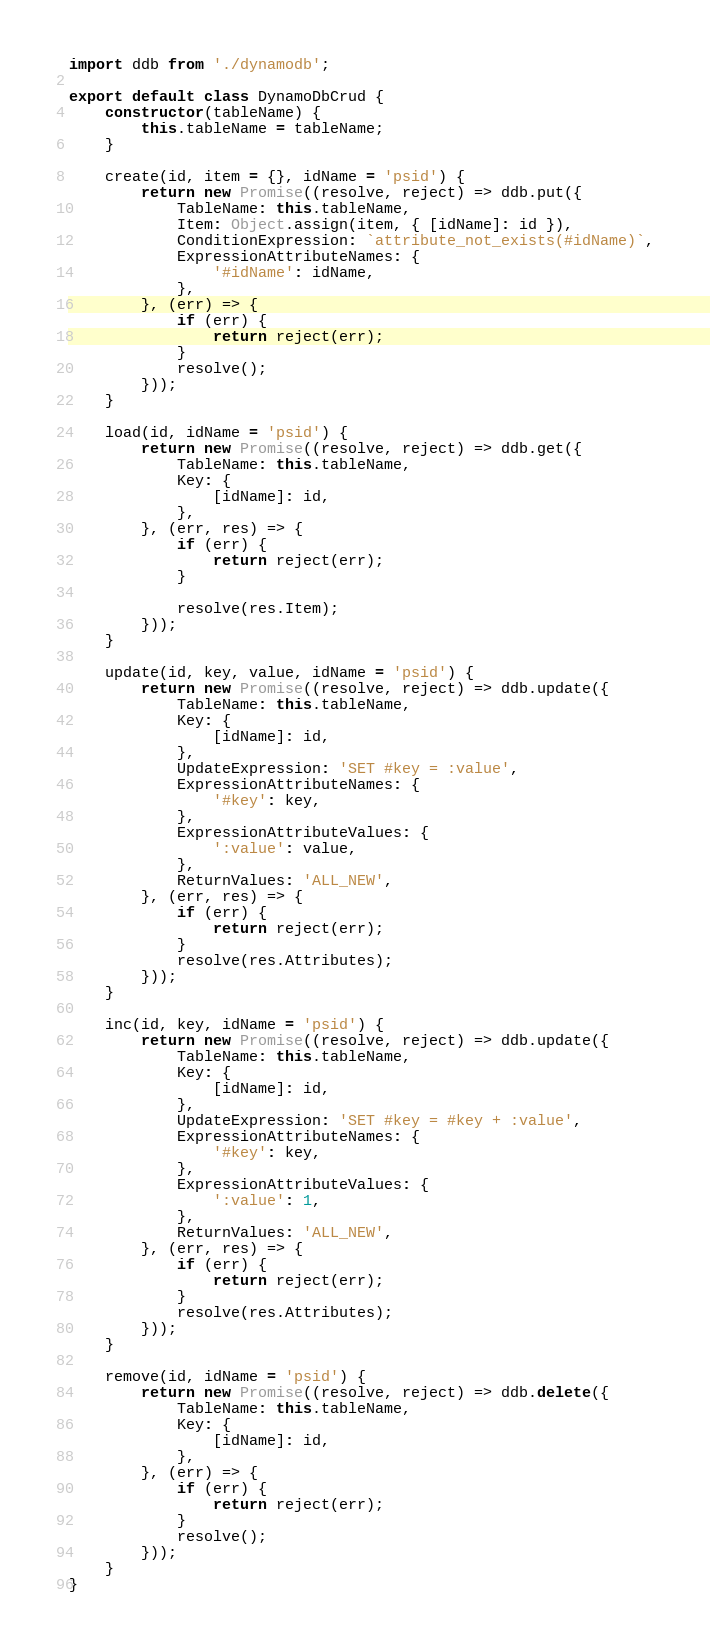<code> <loc_0><loc_0><loc_500><loc_500><_JavaScript_>import ddb from './dynamodb';

export default class DynamoDbCrud {
    constructor(tableName) {
        this.tableName = tableName;
    }

    create(id, item = {}, idName = 'psid') {
        return new Promise((resolve, reject) => ddb.put({
            TableName: this.tableName,
            Item: Object.assign(item, { [idName]: id }),
            ConditionExpression: `attribute_not_exists(#idName)`,
            ExpressionAttributeNames: {
                '#idName': idName,
            },
        }, (err) => {
            if (err) {
                return reject(err);
            }
            resolve();
        }));
    }

    load(id, idName = 'psid') {
        return new Promise((resolve, reject) => ddb.get({
            TableName: this.tableName,
            Key: {
                [idName]: id,
            },
        }, (err, res) => {
            if (err) {
                return reject(err);
            }

            resolve(res.Item);
        }));
    }

    update(id, key, value, idName = 'psid') {
        return new Promise((resolve, reject) => ddb.update({
            TableName: this.tableName,
            Key: {
                [idName]: id,
            },
            UpdateExpression: 'SET #key = :value',
            ExpressionAttributeNames: {
                '#key': key,
            },
            ExpressionAttributeValues: {
                ':value': value,
            },
            ReturnValues: 'ALL_NEW',
        }, (err, res) => {
            if (err) {
                return reject(err);
            }
            resolve(res.Attributes);
        }));
    }

    inc(id, key, idName = 'psid') {
        return new Promise((resolve, reject) => ddb.update({
            TableName: this.tableName,
            Key: {
                [idName]: id,
            },
            UpdateExpression: 'SET #key = #key + :value',
            ExpressionAttributeNames: {
                '#key': key,
            },
            ExpressionAttributeValues: {
                ':value': 1,
            },
            ReturnValues: 'ALL_NEW',
        }, (err, res) => {
            if (err) {
                return reject(err);
            }
            resolve(res.Attributes);
        }));
    }

    remove(id, idName = 'psid') {
        return new Promise((resolve, reject) => ddb.delete({
            TableName: this.tableName,
            Key: {
                [idName]: id,
            },
        }, (err) => {
            if (err) {
                return reject(err);
            }
            resolve();
        }));
    }
}
</code> 